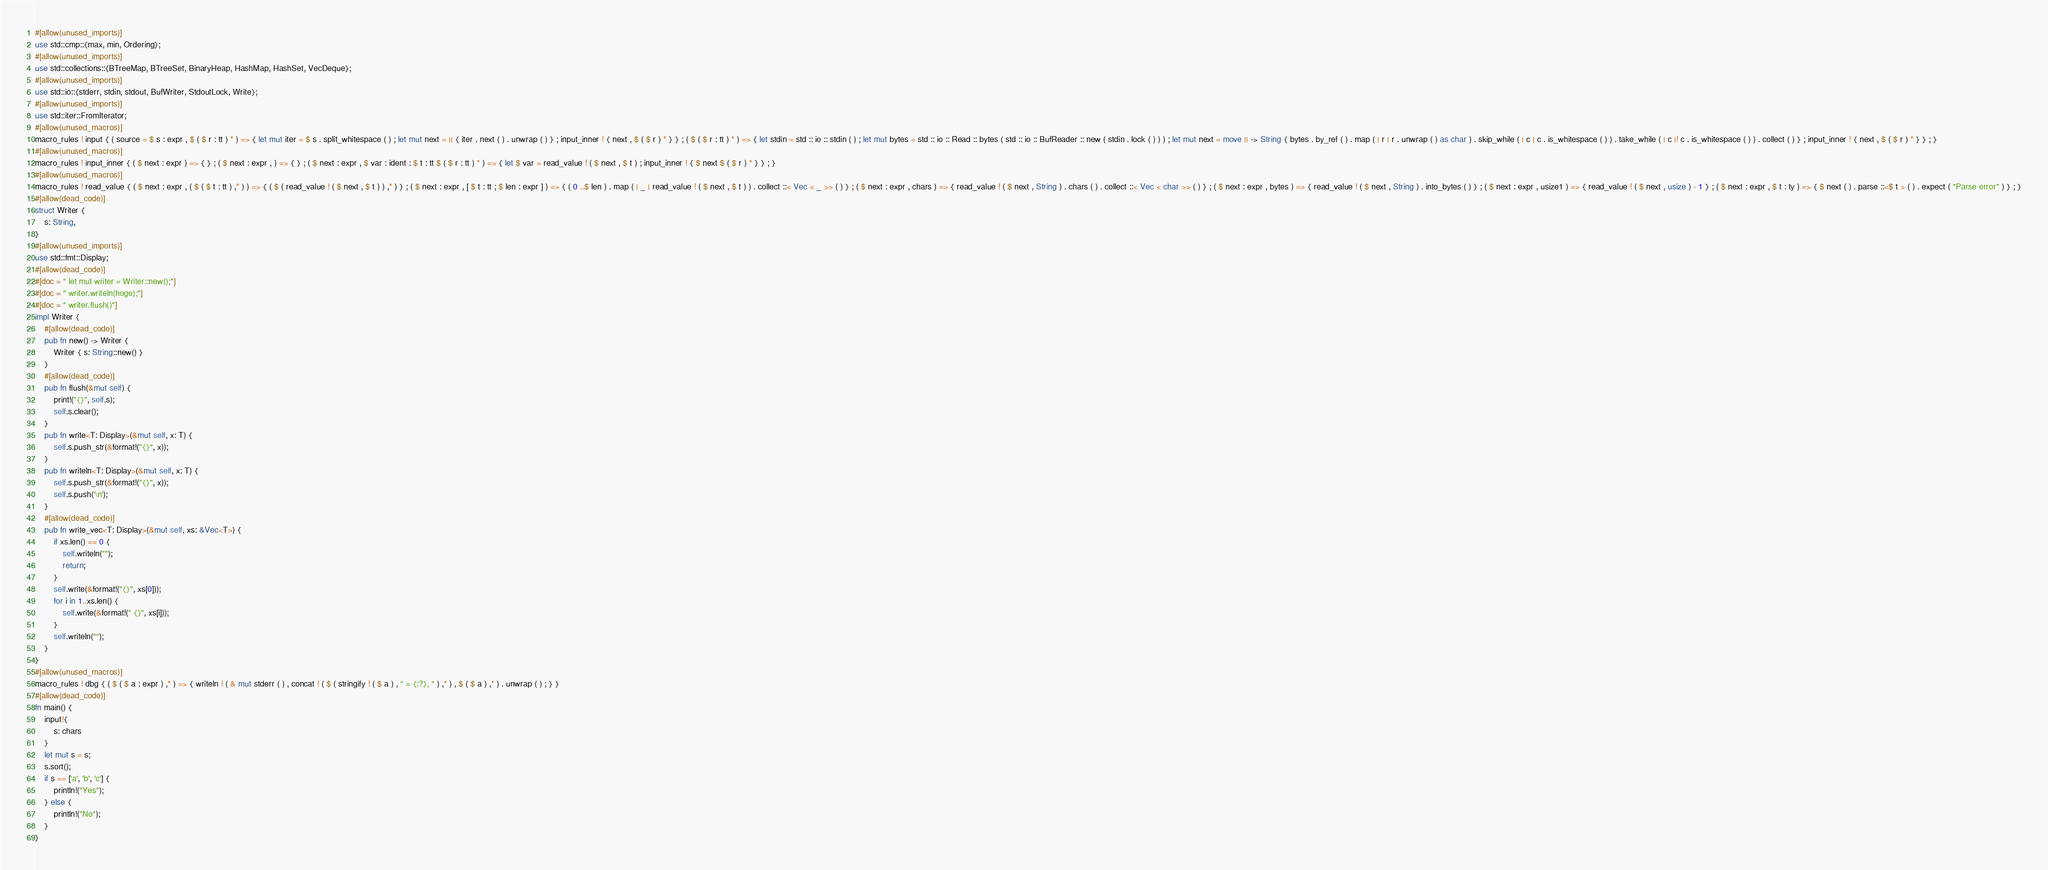Convert code to text. <code><loc_0><loc_0><loc_500><loc_500><_Rust_>#[allow(unused_imports)]
use std::cmp::{max, min, Ordering};
#[allow(unused_imports)]
use std::collections::{BTreeMap, BTreeSet, BinaryHeap, HashMap, HashSet, VecDeque};
#[allow(unused_imports)]
use std::io::{stderr, stdin, stdout, BufWriter, StdoutLock, Write};
#[allow(unused_imports)]
use std::iter::FromIterator;
#[allow(unused_macros)]
macro_rules ! input { ( source = $ s : expr , $ ( $ r : tt ) * ) => { let mut iter = $ s . split_whitespace ( ) ; let mut next = || { iter . next ( ) . unwrap ( ) } ; input_inner ! { next , $ ( $ r ) * } } ; ( $ ( $ r : tt ) * ) => { let stdin = std :: io :: stdin ( ) ; let mut bytes = std :: io :: Read :: bytes ( std :: io :: BufReader :: new ( stdin . lock ( ) ) ) ; let mut next = move || -> String { bytes . by_ref ( ) . map ( | r | r . unwrap ( ) as char ) . skip_while ( | c | c . is_whitespace ( ) ) . take_while ( | c |! c . is_whitespace ( ) ) . collect ( ) } ; input_inner ! { next , $ ( $ r ) * } } ; }
#[allow(unused_macros)]
macro_rules ! input_inner { ( $ next : expr ) => { } ; ( $ next : expr , ) => { } ; ( $ next : expr , $ var : ident : $ t : tt $ ( $ r : tt ) * ) => { let $ var = read_value ! ( $ next , $ t ) ; input_inner ! { $ next $ ( $ r ) * } } ; }
#[allow(unused_macros)]
macro_rules ! read_value { ( $ next : expr , ( $ ( $ t : tt ) ,* ) ) => { ( $ ( read_value ! ( $ next , $ t ) ) ,* ) } ; ( $ next : expr , [ $ t : tt ; $ len : expr ] ) => { ( 0 ..$ len ) . map ( | _ | read_value ! ( $ next , $ t ) ) . collect ::< Vec < _ >> ( ) } ; ( $ next : expr , chars ) => { read_value ! ( $ next , String ) . chars ( ) . collect ::< Vec < char >> ( ) } ; ( $ next : expr , bytes ) => { read_value ! ( $ next , String ) . into_bytes ( ) } ; ( $ next : expr , usize1 ) => { read_value ! ( $ next , usize ) - 1 } ; ( $ next : expr , $ t : ty ) => { $ next ( ) . parse ::<$ t > ( ) . expect ( "Parse error" ) } ; }
#[allow(dead_code)]
struct Writer {
    s: String,
}
#[allow(unused_imports)]
use std::fmt::Display;
#[allow(dead_code)]
#[doc = " let mut writer = Writer::new();"]
#[doc = " writer.writeln(hoge);"]
#[doc = " writer.flush()"]
impl Writer {
    #[allow(dead_code)]
    pub fn new() -> Writer {
        Writer { s: String::new() }
    }
    #[allow(dead_code)]
    pub fn flush(&mut self) {
        print!("{}", self.s);
        self.s.clear();
    }
    pub fn write<T: Display>(&mut self, x: T) {
        self.s.push_str(&format!("{}", x));
    }
    pub fn writeln<T: Display>(&mut self, x: T) {
        self.s.push_str(&format!("{}", x));
        self.s.push('\n');
    }
    #[allow(dead_code)]
    pub fn write_vec<T: Display>(&mut self, xs: &Vec<T>) {
        if xs.len() == 0 {
            self.writeln("");
            return;
        }
        self.write(&format!("{}", xs[0]));
        for i in 1..xs.len() {
            self.write(&format!(" {}", xs[i]));
        }
        self.writeln("");
    }
}
#[allow(unused_macros)]
macro_rules ! dbg { ( $ ( $ a : expr ) ,* ) => { writeln ! ( & mut stderr ( ) , concat ! ( $ ( stringify ! ( $ a ) , " = {:?}, " ) ,* ) , $ ( $ a ) ,* ) . unwrap ( ) ; } }
#[allow(dead_code)]
fn main() {
    input!{
        s: chars
    }
    let mut s = s;
    s.sort();
    if s == ['a', 'b', 'c'] {
        println!("Yes");
    } else {
        println!("No");
    }
}</code> 